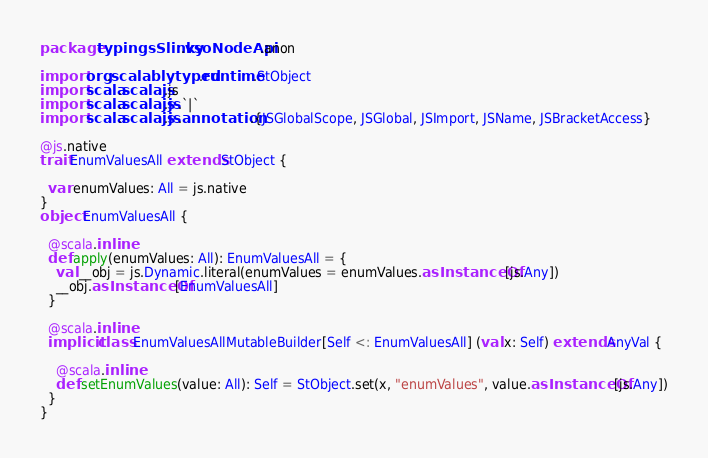Convert code to text. <code><loc_0><loc_0><loc_500><loc_500><_Scala_>package typingsSlinky.vsoNodeApi.anon

import org.scalablytyped.runtime.StObject
import scala.scalajs.js
import scala.scalajs.js.`|`
import scala.scalajs.js.annotation.{JSGlobalScope, JSGlobal, JSImport, JSName, JSBracketAccess}

@js.native
trait EnumValuesAll extends StObject {
  
  var enumValues: All = js.native
}
object EnumValuesAll {
  
  @scala.inline
  def apply(enumValues: All): EnumValuesAll = {
    val __obj = js.Dynamic.literal(enumValues = enumValues.asInstanceOf[js.Any])
    __obj.asInstanceOf[EnumValuesAll]
  }
  
  @scala.inline
  implicit class EnumValuesAllMutableBuilder[Self <: EnumValuesAll] (val x: Self) extends AnyVal {
    
    @scala.inline
    def setEnumValues(value: All): Self = StObject.set(x, "enumValues", value.asInstanceOf[js.Any])
  }
}
</code> 